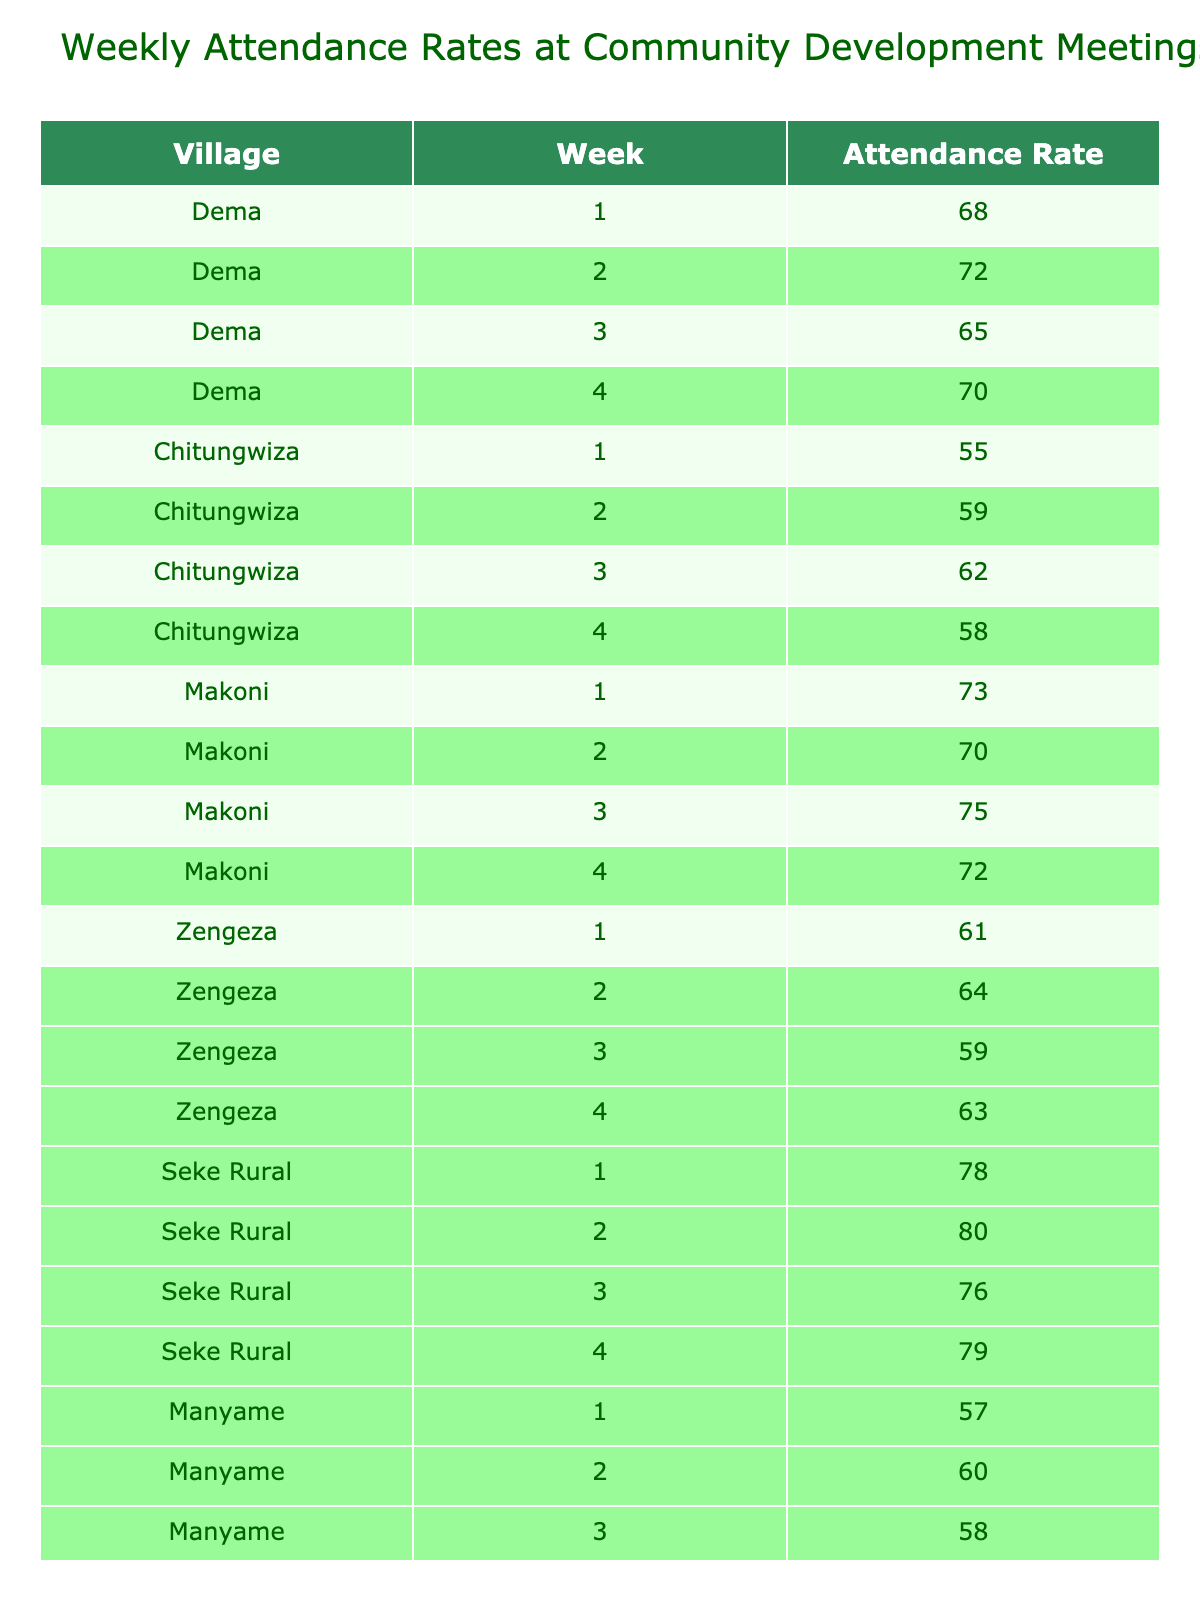What was the highest attendance rate in Dema? The highest attendance rate in Dema is found by checking the values for each week. The rates are 68, 72, 65, and 70. The maximum of these numbers is 72.
Answer: 72 What was the average attendance rate for Makoni? To find the average attendance rate for Makoni, sum the rates for the four weeks: (73 + 70 + 75 + 72) = 290, and then divide by 4, resulting in 290 / 4 = 72.5.
Answer: 72.5 Did Zengeza have any week with an attendance rate above 65? Looking at the attendance rates for Zengeza—61, 64, 59, and 63—none of these values exceed 65.
Answer: No What is the total attendance rate for Seke Rural across all weeks? To find the total for Seke Rural, add the weekly rates: (78 + 80 + 76 + 79) = 313.
Answer: 313 Which village had the lowest attendance rate in week 3? In week 3, the attendance rates are: Dema (65), Chitungwiza (62), Makoni (75), Zengeza (59), Seke Rural (76), Manyame (58), and Beatrice (67). The lowest rate here is 58 from Manyame.
Answer: Manyame What was the increase or decrease in attendance rate for Beatrice from week 1 to week 4? The attendance rate for Beatrice in week 1 is 69 and in week 4 is 70. The change is 70 - 69 = 1, indicating an increase.
Answer: Increase of 1 Which village had the most consistent attendance rates over the four weeks? To determine consistency, we assess the range of attendance rates for each village. The ranges are: Dema (72 - 65 = 7), Chitungwiza (62 - 55 = 7), Makoni (75 - 70 = 5), Zengeza (64 - 59 = 5), Seke Rural (80 - 76 = 4), Manyame (61 - 57 = 4), and Beatrice (71 - 67 = 4). Seke Rural had the smallest range of 4, indicating it had the most consistent rates.
Answer: Seke Rural What is the overall average attendance rate across all villages for week 2? For week 2, the attendance rates are: Dema (72), Chitungwiza (59), Makoni (70), Zengeza (64), Seke Rural (80), Manyame (60), and Beatrice (71). Summing these gives (72 + 59 + 70 + 64 + 80 + 60 + 71) = 476. Dividing by 7 gives the average: 476 / 7 = approximately 68. We can round this to 68.
Answer: 68 Which week's attendance rate in Zengeza had the largest increase from the previous week? Looking at Zengeza's rates: week 1 (61), week 2 (64), week 3 (59), and week 4 (63). The changes are: from week 1 to week 2 (64 - 61 = 3), week 2 to week 3 (59 - 64 = -5), and week 3 to week 4 (63 - 59 = 4). The largest increase is from week 1 to week 2 with an increase of 3.
Answer: Week 2 What was the difference between the highest and lowest attendance rate recorded in Chitungwiza? For Chitungwiza, the rates are 55, 59, 62, and 58. The highest rate is 62 and the lowest is 55, so the difference is 62 - 55 = 7.
Answer: 7 